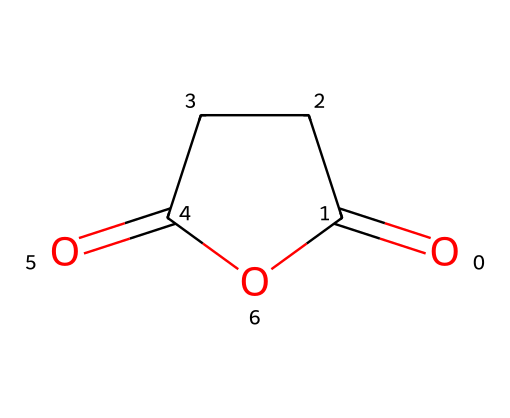How many carbon atoms are in succinic anhydride? The SMILES representation shows that there are 4 carbon atoms in the structure illustrated by the 'C' characters surrounding the anhydride group.
Answer: 4 What functional groups are present in succinic anhydride? The structure contains an anhydride group and a carbonyl group, indicated by the two (=O) which are characteristic features of anhydrides.
Answer: anhydride, carbonyl Is succinic anhydride a cyclic compound? The presence of the number '1' in the SMILES indicates that there is a ring structure in the compound, confirming that it is indeed a cyclic compound.
Answer: yes What is the molecular formula of succinic anhydride? To derive the molecular formula, you count the atoms represented in the SMILES: C4, H4, and O3, leading to the overall formula C4H4O3.
Answer: C4H4O3 Which part of the molecule indicates it is an acid anhydride? The combination of two carbonyl groups adjacent to an oxygen atom, which forms the anhydride bond, is a key characteristic of acid anhydrides.
Answer: anhydride bond How many double bonds are present in succinic anhydride? In examining the structure, there are two double bonds associated with the two carbonyl groups, each denoted by (=O) in the SMILES representation.
Answer: 2 